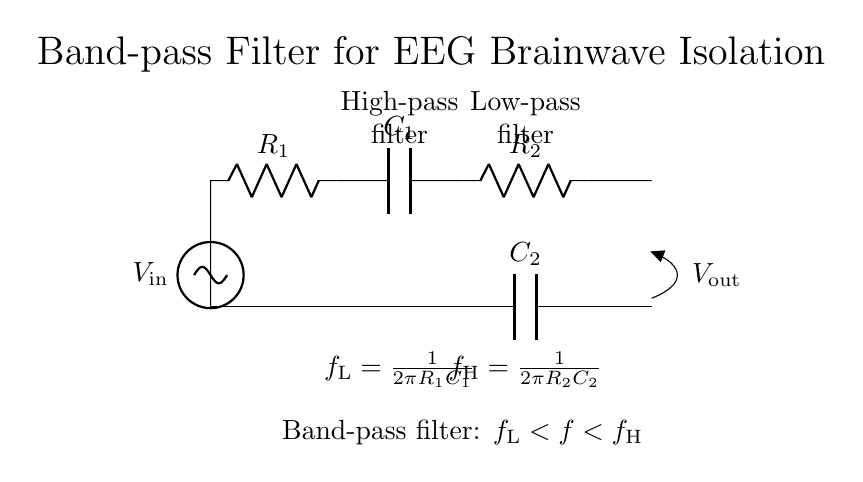What is the input voltage of the circuit? The input voltage is labeled as V_in, which indicates the potential difference supplied to the circuit.
Answer: V_in What components are used in the high-pass filter section? The high-pass filter section includes a resistor R_1 and a capacitor C_1, which together allow signals higher than a certain frequency to pass.
Answer: R_1 and C_1 What is the purpose of the low-pass filter section in this circuit? The low-pass filter section, consisting of a resistor R_2 and a capacitor C_2, is designed to allow signals lower than a specific frequency to pass while attenuating higher frequencies.
Answer: To allow low frequencies What is the formula for the lower cutoff frequency? The formula for the lower cutoff frequency, f_L, is defined as f_L = 1/(2πR_1C_1). This calculation determines the threshold frequency below which signals are significantly attenuated.
Answer: f_L = 1/(2πR_1C_1) In this band-pass filter, what frequency range is isolated or passed? The frequency range that is passed is defined as f_L < f < f_H, meaning frequencies between the lower cutoff frequency f_L and the upper cutoff frequency f_H are isolated.
Answer: f_L < f < f_H What is the output voltage of this filter circuit? The output voltage is labeled as V_out, which signifies the voltage measured across the output terminals following the filter process, showing the filtered brainwave signals.
Answer: V_out 